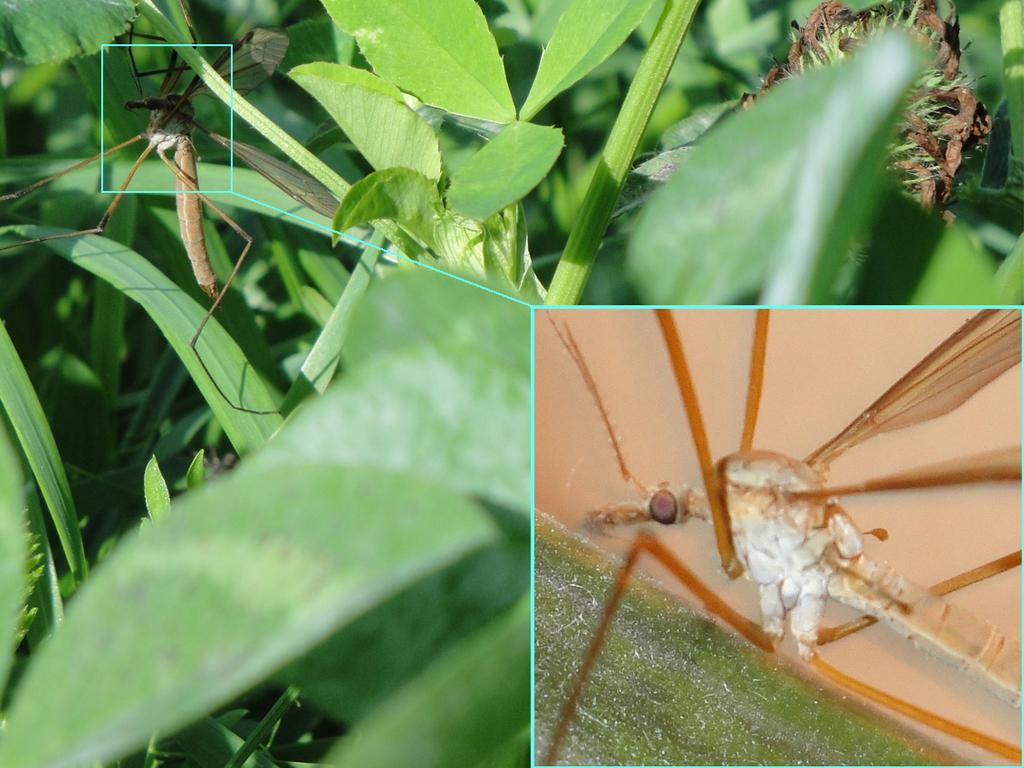What is present in the image? There is an insect in the image. Where is the insect located? The insect is on a leaf. Is there any additional information about the insect in the image? Yes, there is a zoomed photograph of the insect to the right side of the image. What type of chalk is the father using to draw on the twig in the image? There is no father or chalk present in the image, nor is there any drawing on a twig. 